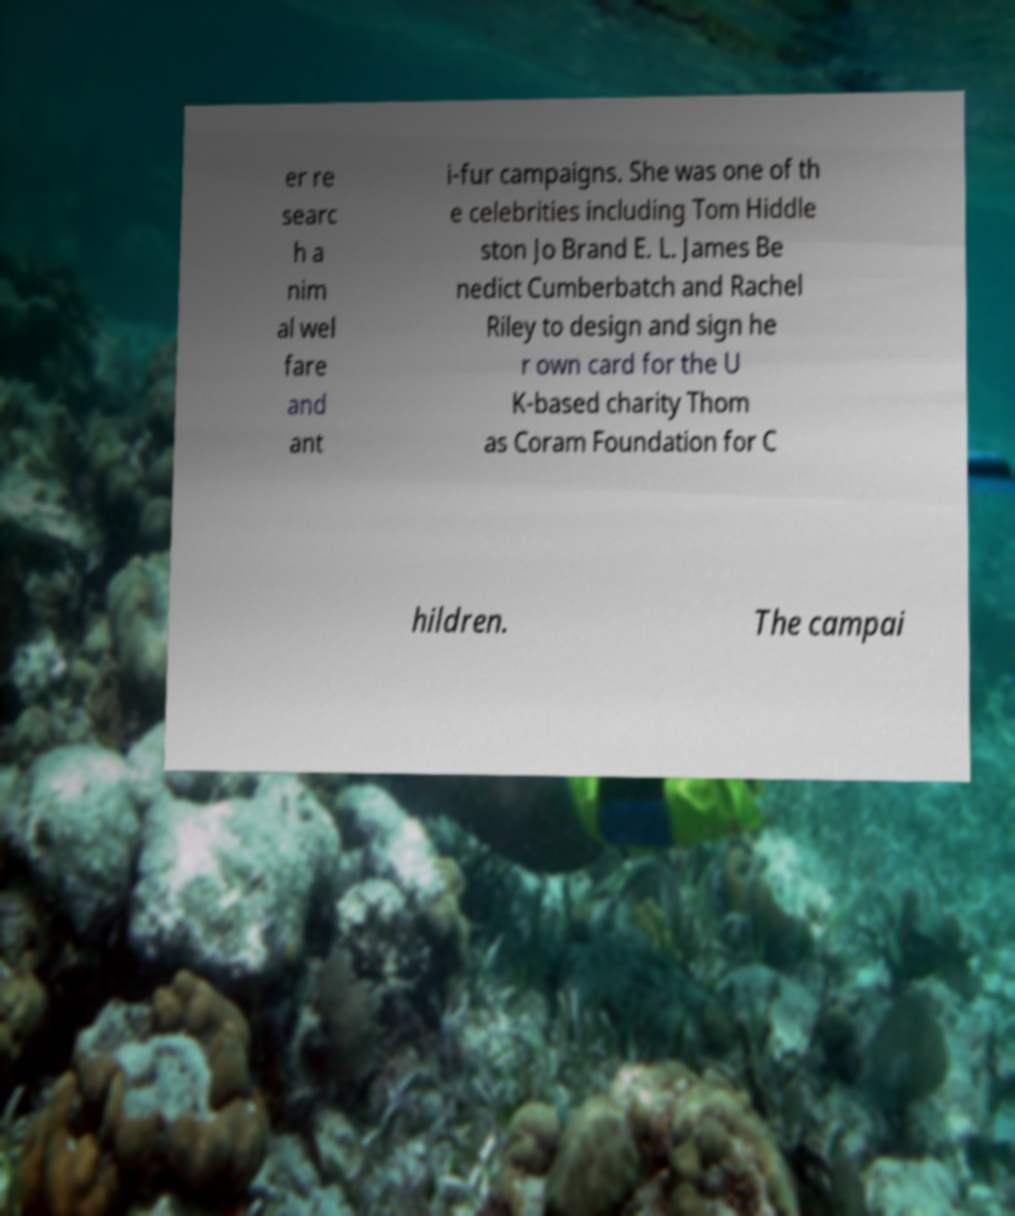Please read and relay the text visible in this image. What does it say? er re searc h a nim al wel fare and ant i-fur campaigns. She was one of th e celebrities including Tom Hiddle ston Jo Brand E. L. James Be nedict Cumberbatch and Rachel Riley to design and sign he r own card for the U K-based charity Thom as Coram Foundation for C hildren. The campai 